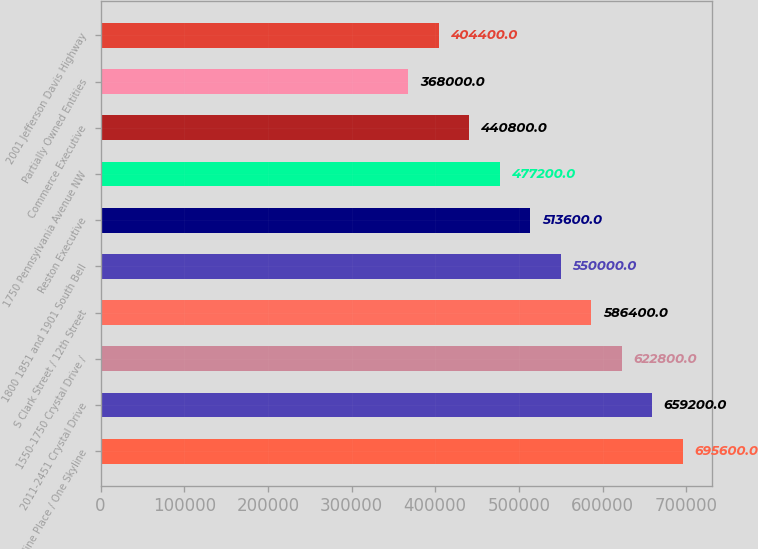Convert chart to OTSL. <chart><loc_0><loc_0><loc_500><loc_500><bar_chart><fcel>Skyline Place / One Skyline<fcel>2011-2451 Crystal Drive<fcel>1550-1750 Crystal Drive /<fcel>S Clark Street / 12th Street<fcel>1800 1851 and 1901 South Bell<fcel>Reston Executive<fcel>1750 Pennsylvania Avenue NW<fcel>Commerce Executive<fcel>Partially Owned Entities<fcel>2001 Jefferson Davis Highway<nl><fcel>695600<fcel>659200<fcel>622800<fcel>586400<fcel>550000<fcel>513600<fcel>477200<fcel>440800<fcel>368000<fcel>404400<nl></chart> 